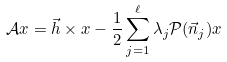<formula> <loc_0><loc_0><loc_500><loc_500>\mathcal { A } x = \vec { h } \times x - \frac { 1 } { 2 } \sum _ { j = 1 } ^ { \ell } \lambda _ { j } \mathcal { P } ( \vec { n } _ { j } ) x</formula> 